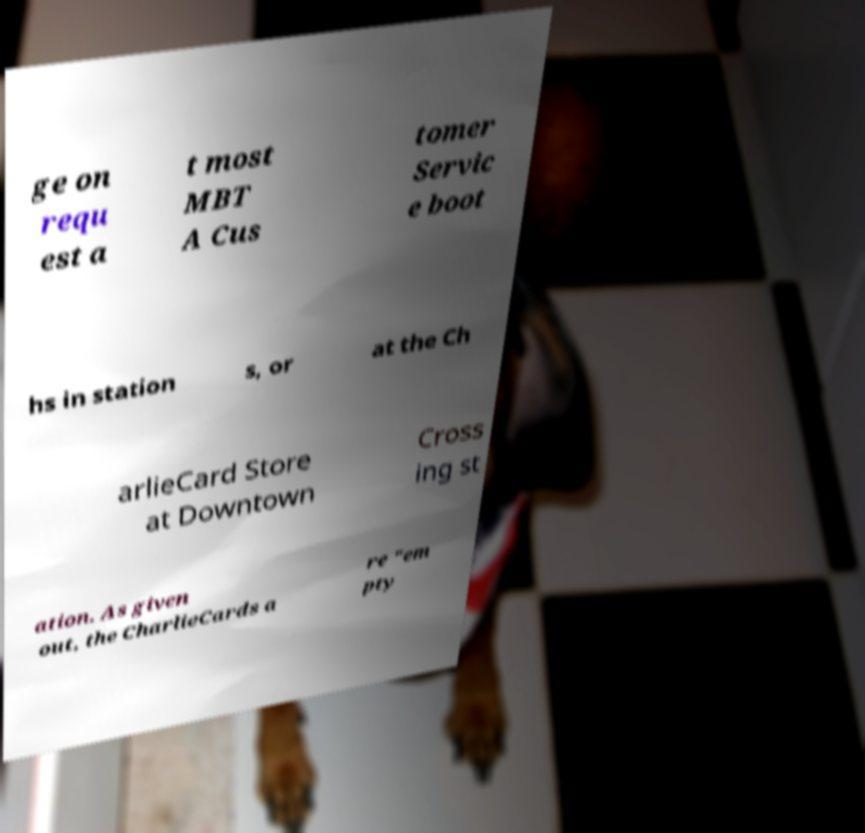Please identify and transcribe the text found in this image. ge on requ est a t most MBT A Cus tomer Servic e boot hs in station s, or at the Ch arlieCard Store at Downtown Cross ing st ation. As given out, the CharlieCards a re "em pty 